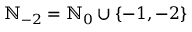<formula> <loc_0><loc_0><loc_500><loc_500>{ \mathbb { N } } _ { - 2 } = { \mathbb { N } } _ { 0 } \cup \{ - 1 , - 2 \}</formula> 